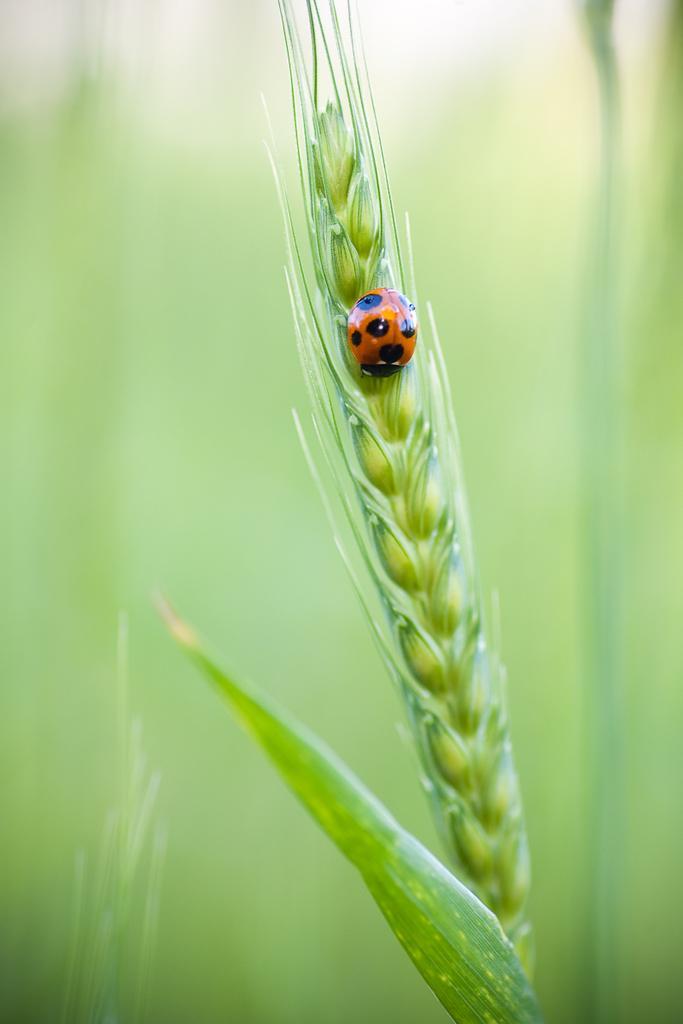Can you describe this image briefly? In this image we can see the grass and there is an insect on the plant. 